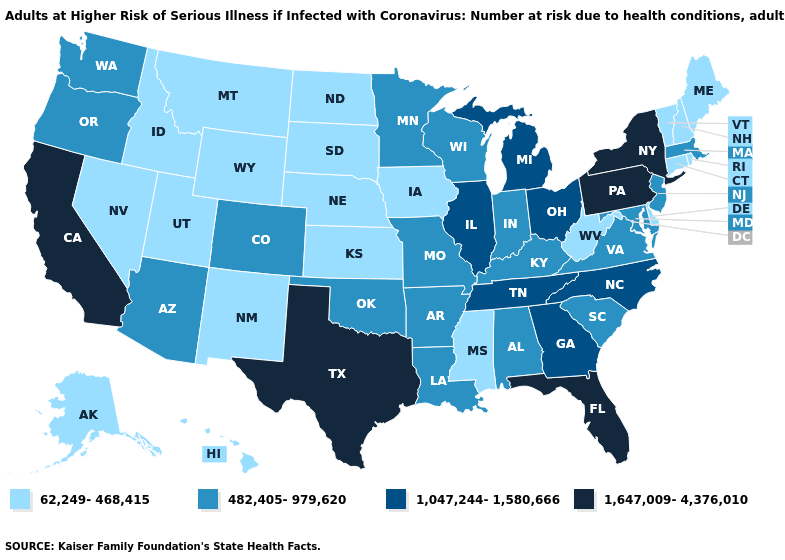Does New York have the highest value in the USA?
Keep it brief. Yes. Name the states that have a value in the range 62,249-468,415?
Short answer required. Alaska, Connecticut, Delaware, Hawaii, Idaho, Iowa, Kansas, Maine, Mississippi, Montana, Nebraska, Nevada, New Hampshire, New Mexico, North Dakota, Rhode Island, South Dakota, Utah, Vermont, West Virginia, Wyoming. Name the states that have a value in the range 62,249-468,415?
Write a very short answer. Alaska, Connecticut, Delaware, Hawaii, Idaho, Iowa, Kansas, Maine, Mississippi, Montana, Nebraska, Nevada, New Hampshire, New Mexico, North Dakota, Rhode Island, South Dakota, Utah, Vermont, West Virginia, Wyoming. Is the legend a continuous bar?
Short answer required. No. Does the map have missing data?
Give a very brief answer. No. What is the value of Montana?
Quick response, please. 62,249-468,415. What is the value of Idaho?
Short answer required. 62,249-468,415. What is the lowest value in states that border Wyoming?
Quick response, please. 62,249-468,415. Among the states that border Arizona , does New Mexico have the lowest value?
Short answer required. Yes. Among the states that border Arizona , which have the lowest value?
Be succinct. Nevada, New Mexico, Utah. What is the value of Pennsylvania?
Write a very short answer. 1,647,009-4,376,010. Name the states that have a value in the range 1,647,009-4,376,010?
Short answer required. California, Florida, New York, Pennsylvania, Texas. Name the states that have a value in the range 1,047,244-1,580,666?
Give a very brief answer. Georgia, Illinois, Michigan, North Carolina, Ohio, Tennessee. Does the first symbol in the legend represent the smallest category?
Keep it brief. Yes. What is the lowest value in the South?
Concise answer only. 62,249-468,415. 